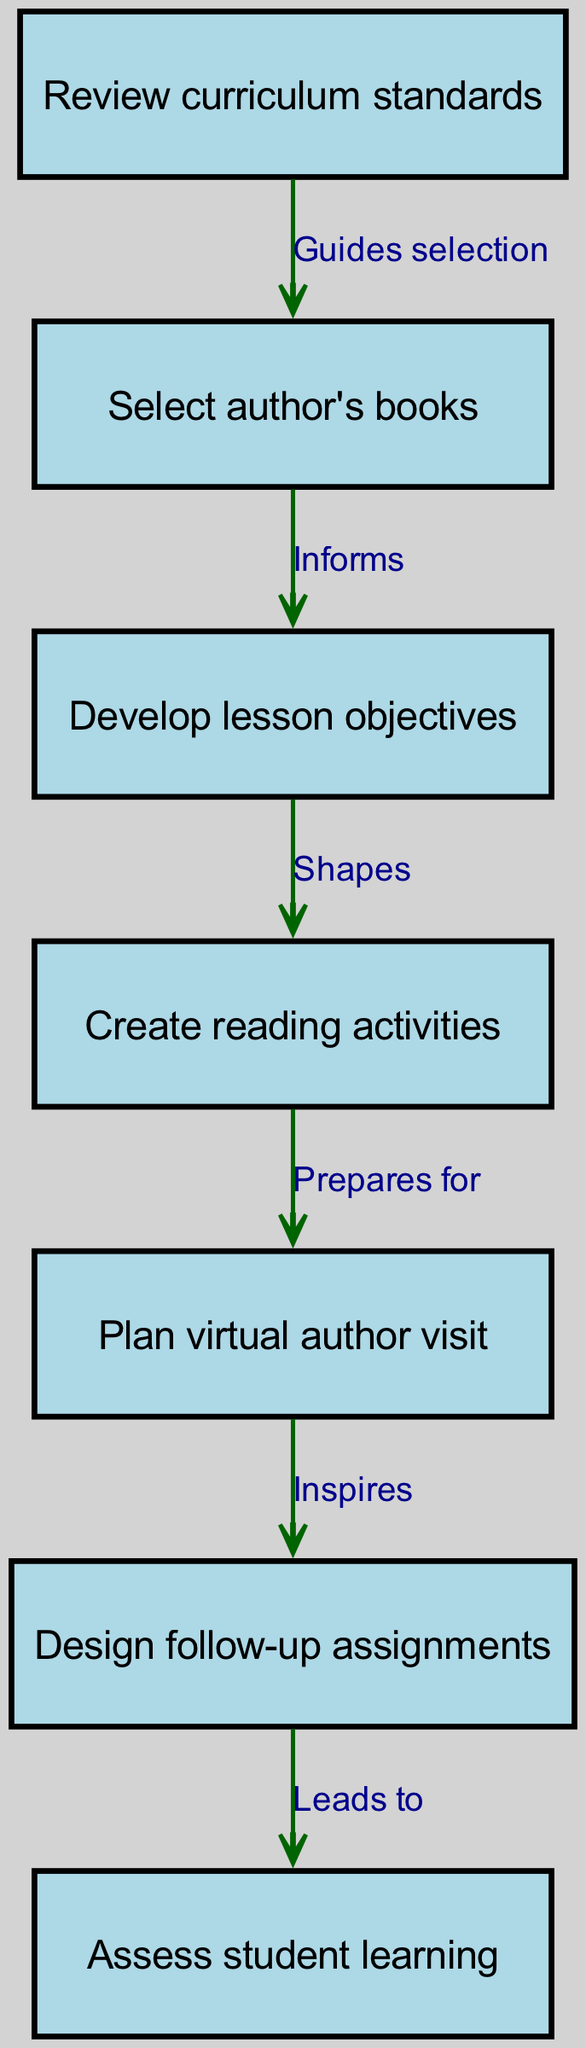What is the first step in the lesson planning process? The first step is labeled as "Review curriculum standards" in the diagram, clearly indicating it as the starting point of the flow.
Answer: Review curriculum standards How many total nodes are in the diagram? By counting the nodes listed in the diagram, we find that there are 7 distinct nodes representing different steps in the planning process.
Answer: 7 What does the edge between "Create reading activities" and "Plan virtual author visit" indicate? The edge labeled "Prepares for" shows that the creation of reading activities is essential preparation for planning the virtual author visit, indicating a direct relationship in the flow.
Answer: Prepares for Which two nodes are connected by the label "Inspires"? According to the diagram, the edge labeled "Inspires" connects the node "Plan virtual author visit" to the node "Design follow-up assignments," reflecting the influence of the author’s visit on subsequent assignments.
Answer: Plan virtual author visit and Design follow-up assignments What follows after "Assess student learning" in the diagram? There are no subsequent nodes or processes listed after "Assess student learning," indicating it is the final step in the process flow, concluding the planning cycle.
Answer: None 